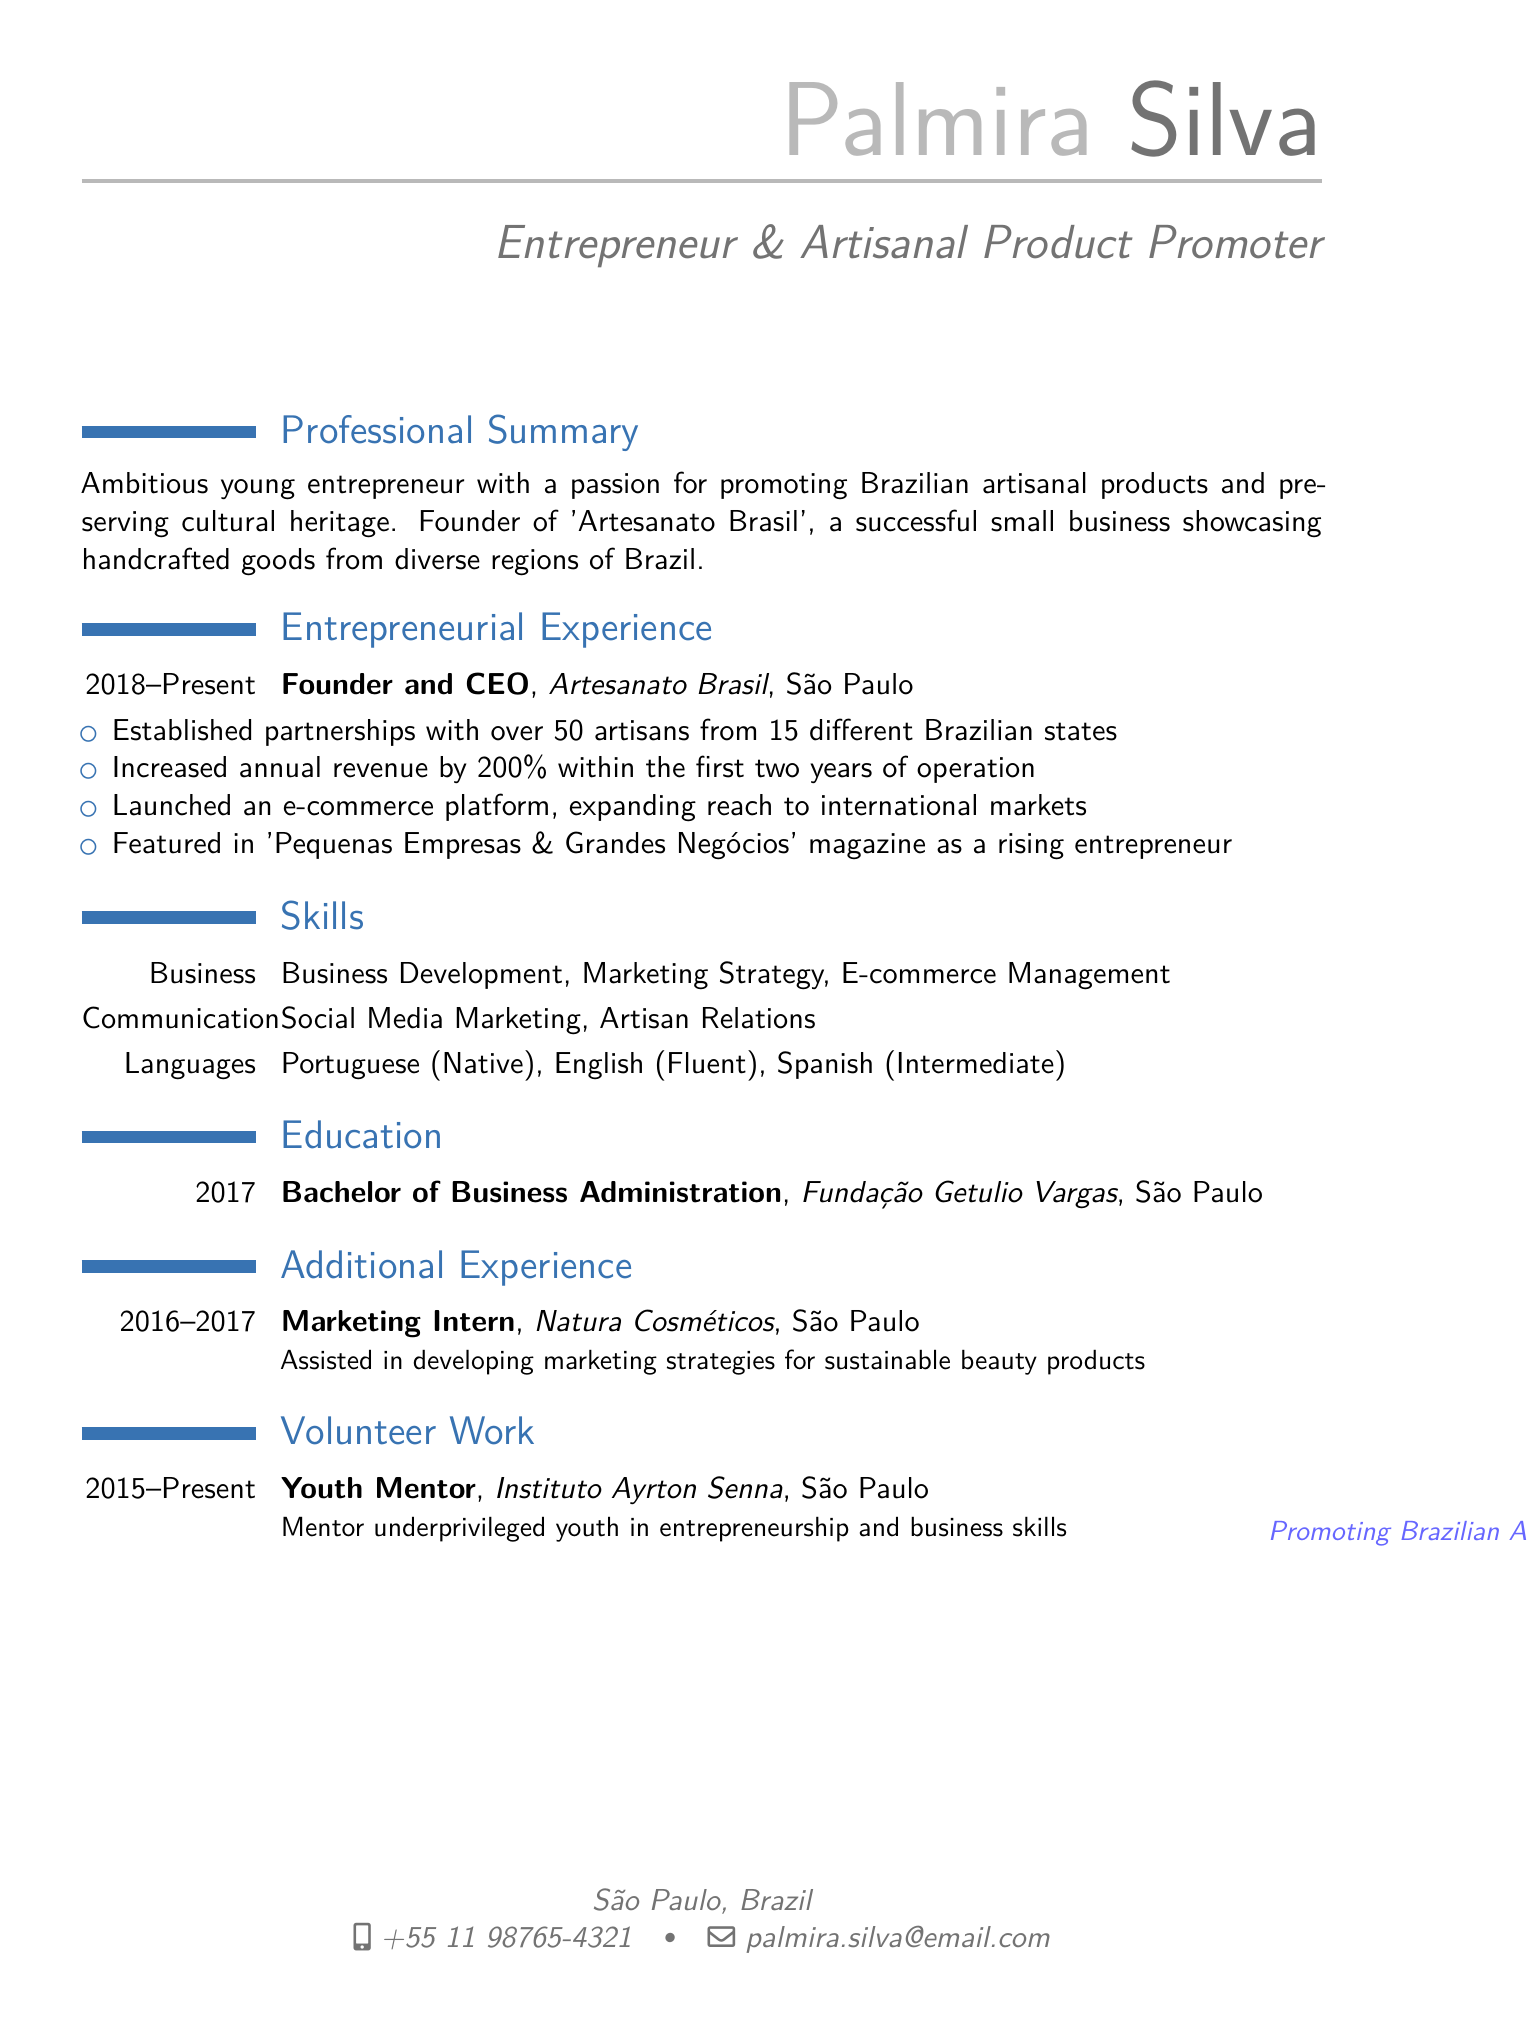What is the name of the business? The name of the business is stated in the entrepreneurial experience section of the document.
Answer: Artesanato Brasil What role does Palmira have in her business? The role is specified in the entrepreneurial experience section, indicating her position.
Answer: Founder and CEO In what year did Palmira start her business? The duration of her business is mentioned in the entrepreneurial experience section, which includes the starting year.
Answer: 2018 How many artisans has Palmira partnered with? The number of artisans partnered with is listed as an achievement in the entrepreneurial experience section.
Answer: Over 50 artisans What magazine featured Palmira as a rising entrepreneur? The publication is mentioned in the entrepreneurial experience section of the resume.
Answer: Pequenas Empresas & Grandes Negócios What degree did Palmira earn? The education section states the type of degree earned by Palmira.
Answer: Bachelor of Business Administration What language proficiency is Palmira listed as having in English? The language skills section details her language abilities.
Answer: Fluent How long has Palmira been a youth mentor? The duration of her volunteer work is provided in the volunteer work section.
Answer: 2015 - Present What is the location of Palmira's business? The location is indicated in the entrepreneurial experience section.
Answer: São Paulo 